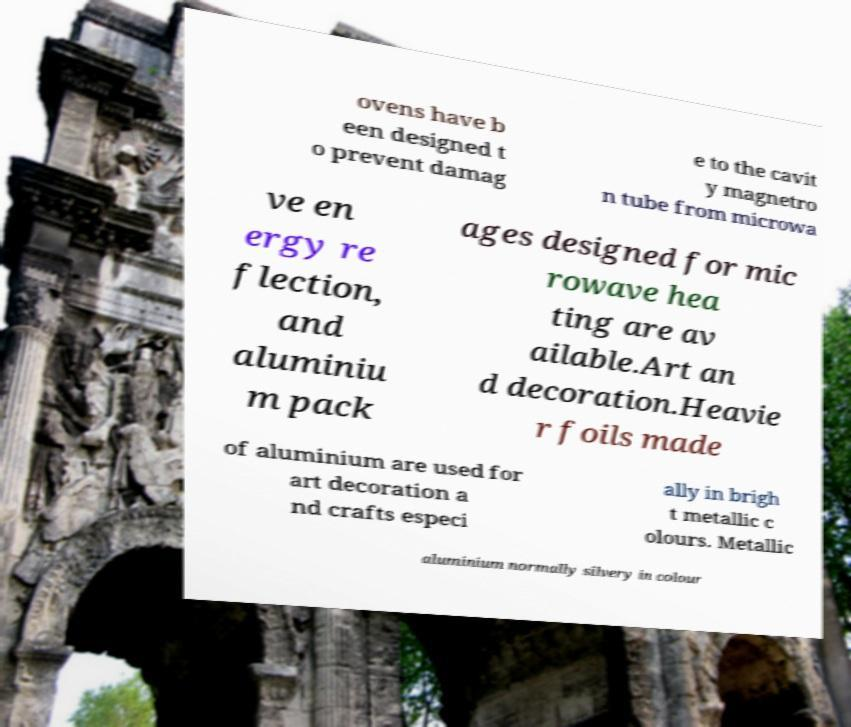Can you read and provide the text displayed in the image?This photo seems to have some interesting text. Can you extract and type it out for me? ovens have b een designed t o prevent damag e to the cavit y magnetro n tube from microwa ve en ergy re flection, and aluminiu m pack ages designed for mic rowave hea ting are av ailable.Art an d decoration.Heavie r foils made of aluminium are used for art decoration a nd crafts especi ally in brigh t metallic c olours. Metallic aluminium normally silvery in colour 